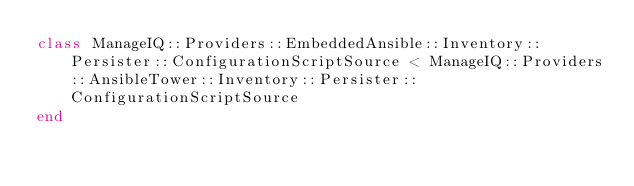<code> <loc_0><loc_0><loc_500><loc_500><_Ruby_>class ManageIQ::Providers::EmbeddedAnsible::Inventory::Persister::ConfigurationScriptSource < ManageIQ::Providers::AnsibleTower::Inventory::Persister::ConfigurationScriptSource
end
</code> 